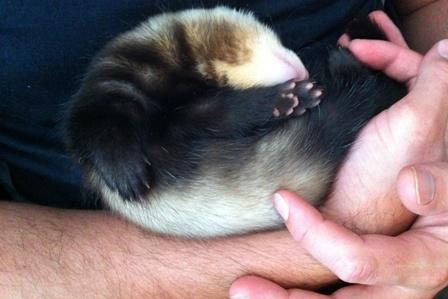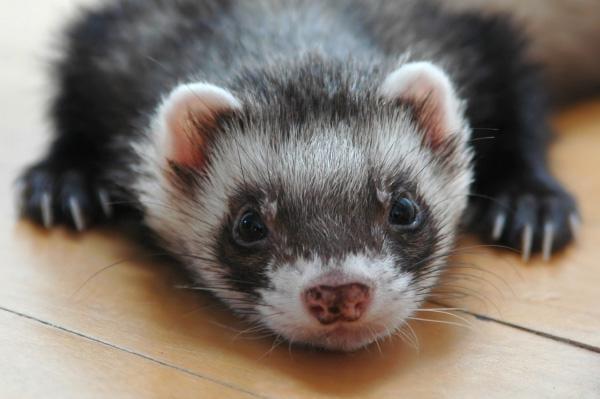The first image is the image on the left, the second image is the image on the right. For the images shown, is this caption "There are exactly two ferrets in the image on the left." true? Answer yes or no. No. 